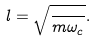<formula> <loc_0><loc_0><loc_500><loc_500>l = \sqrt { \frac { } { m \omega _ { c } } } .</formula> 